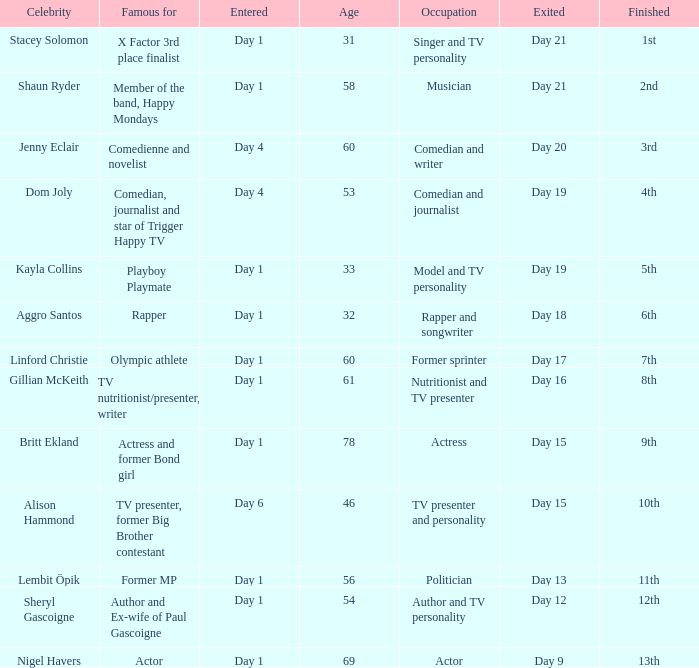What was Dom Joly famous for? Comedian, journalist and star of Trigger Happy TV. 